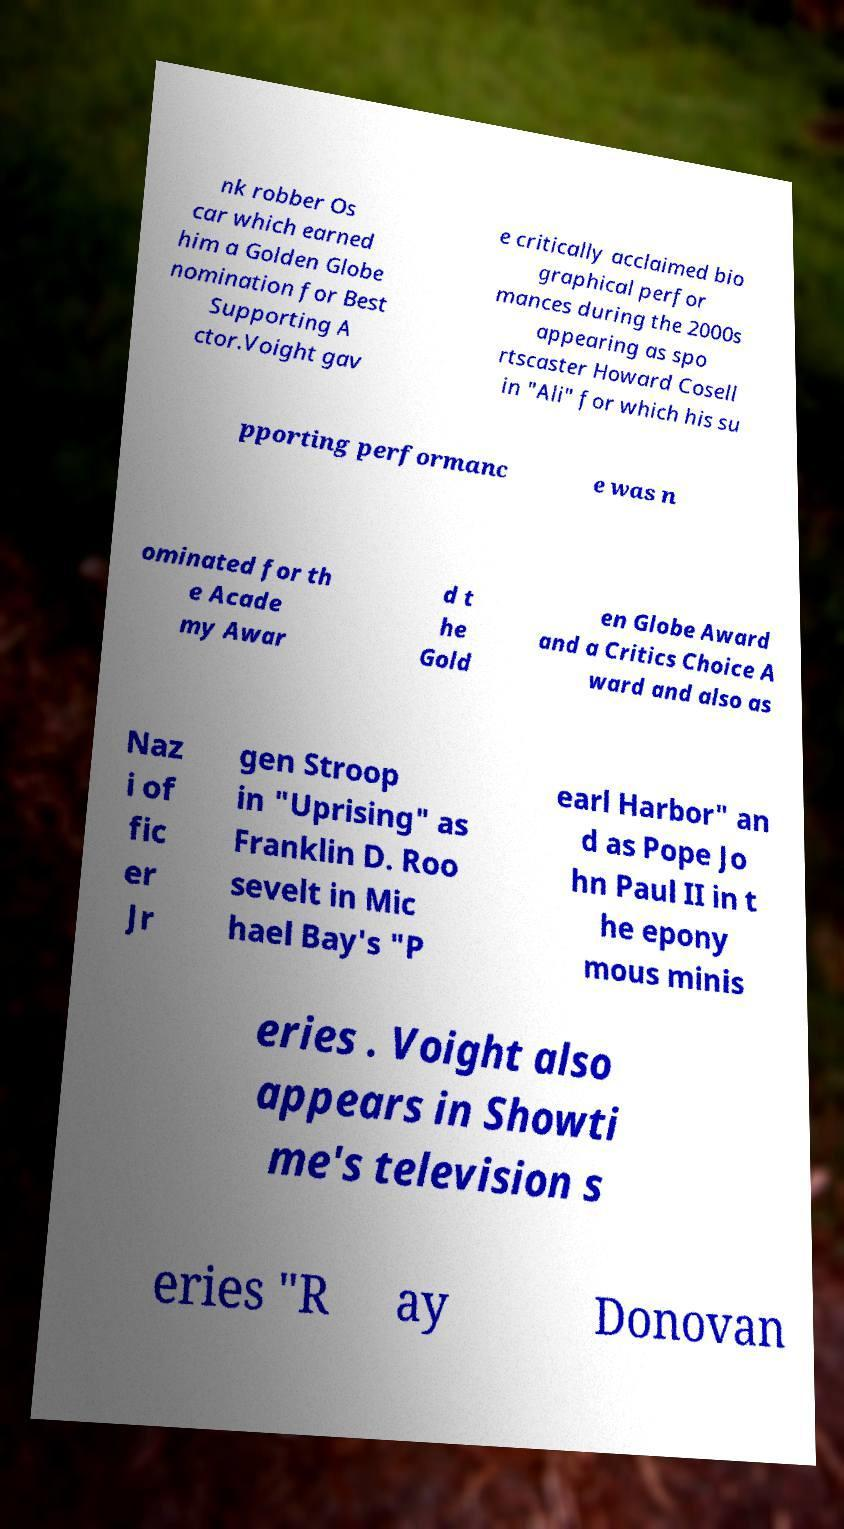Please identify and transcribe the text found in this image. nk robber Os car which earned him a Golden Globe nomination for Best Supporting A ctor.Voight gav e critically acclaimed bio graphical perfor mances during the 2000s appearing as spo rtscaster Howard Cosell in "Ali" for which his su pporting performanc e was n ominated for th e Acade my Awar d t he Gold en Globe Award and a Critics Choice A ward and also as Naz i of fic er Jr gen Stroop in "Uprising" as Franklin D. Roo sevelt in Mic hael Bay's "P earl Harbor" an d as Pope Jo hn Paul II in t he epony mous minis eries . Voight also appears in Showti me's television s eries "R ay Donovan 